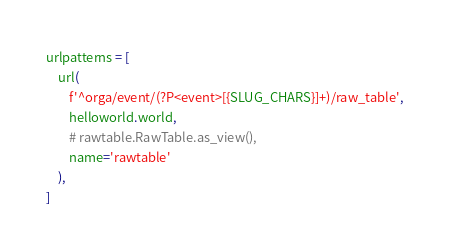<code> <loc_0><loc_0><loc_500><loc_500><_Python_>urlpatterns = [
    url(
        f'^orga/event/(?P<event>[{SLUG_CHARS}]+)/raw_table',
        helloworld.world,
        # rawtable.RawTable.as_view(),
        name='rawtable'
    ),
]
</code> 